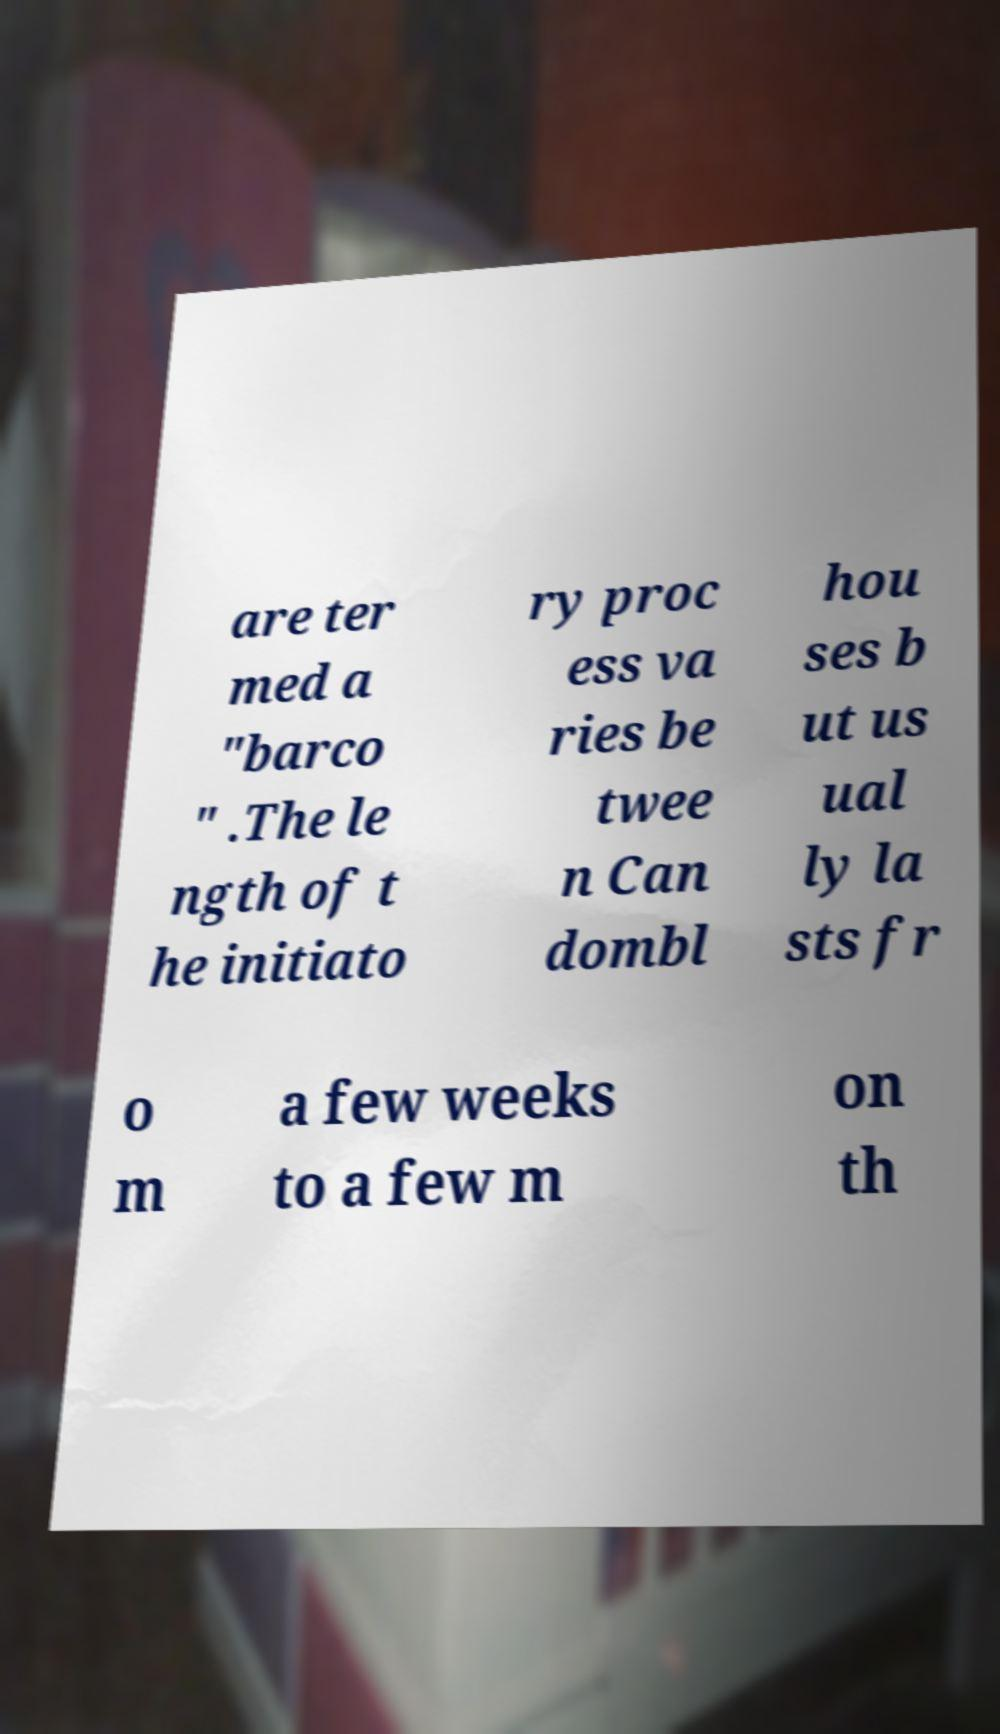Please read and relay the text visible in this image. What does it say? are ter med a "barco " .The le ngth of t he initiato ry proc ess va ries be twee n Can dombl hou ses b ut us ual ly la sts fr o m a few weeks to a few m on th 